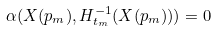<formula> <loc_0><loc_0><loc_500><loc_500>\alpha ( X ( p _ { m } ) , H _ { t _ { m } } ^ { - 1 } ( X ( p _ { m } ) ) ) = 0</formula> 